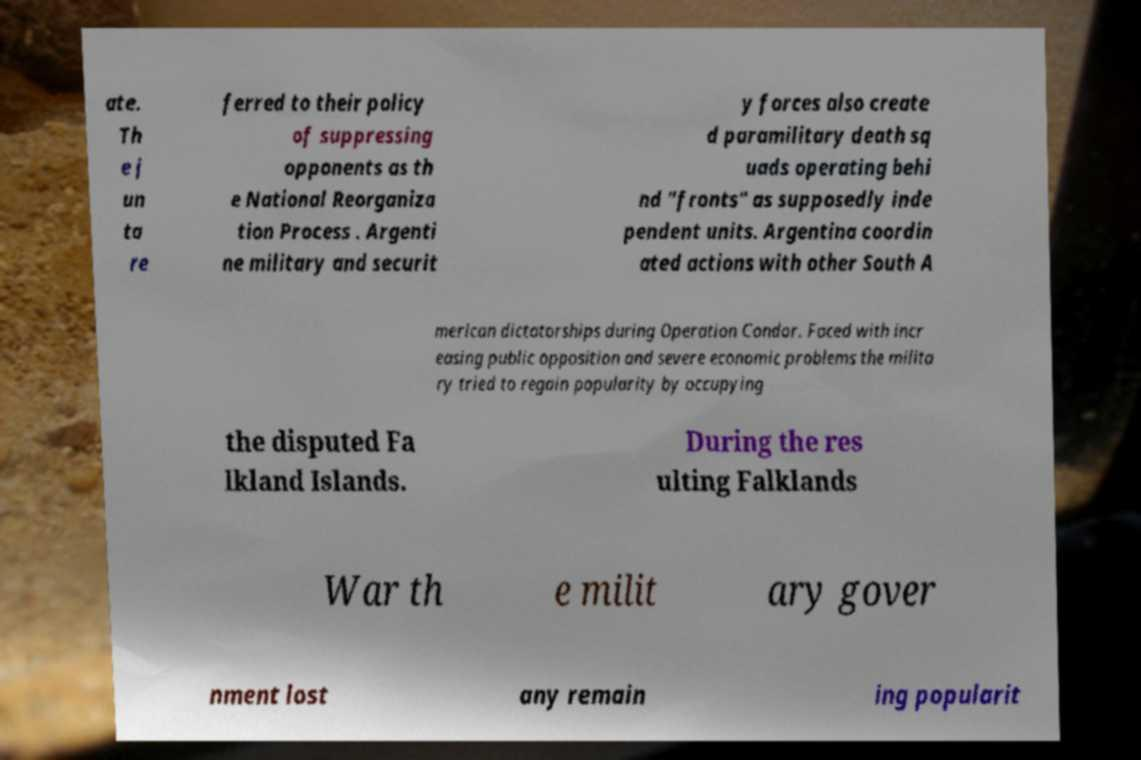Can you accurately transcribe the text from the provided image for me? ate. Th e j un ta re ferred to their policy of suppressing opponents as th e National Reorganiza tion Process . Argenti ne military and securit y forces also create d paramilitary death sq uads operating behi nd "fronts" as supposedly inde pendent units. Argentina coordin ated actions with other South A merican dictatorships during Operation Condor. Faced with incr easing public opposition and severe economic problems the milita ry tried to regain popularity by occupying the disputed Fa lkland Islands. During the res ulting Falklands War th e milit ary gover nment lost any remain ing popularit 